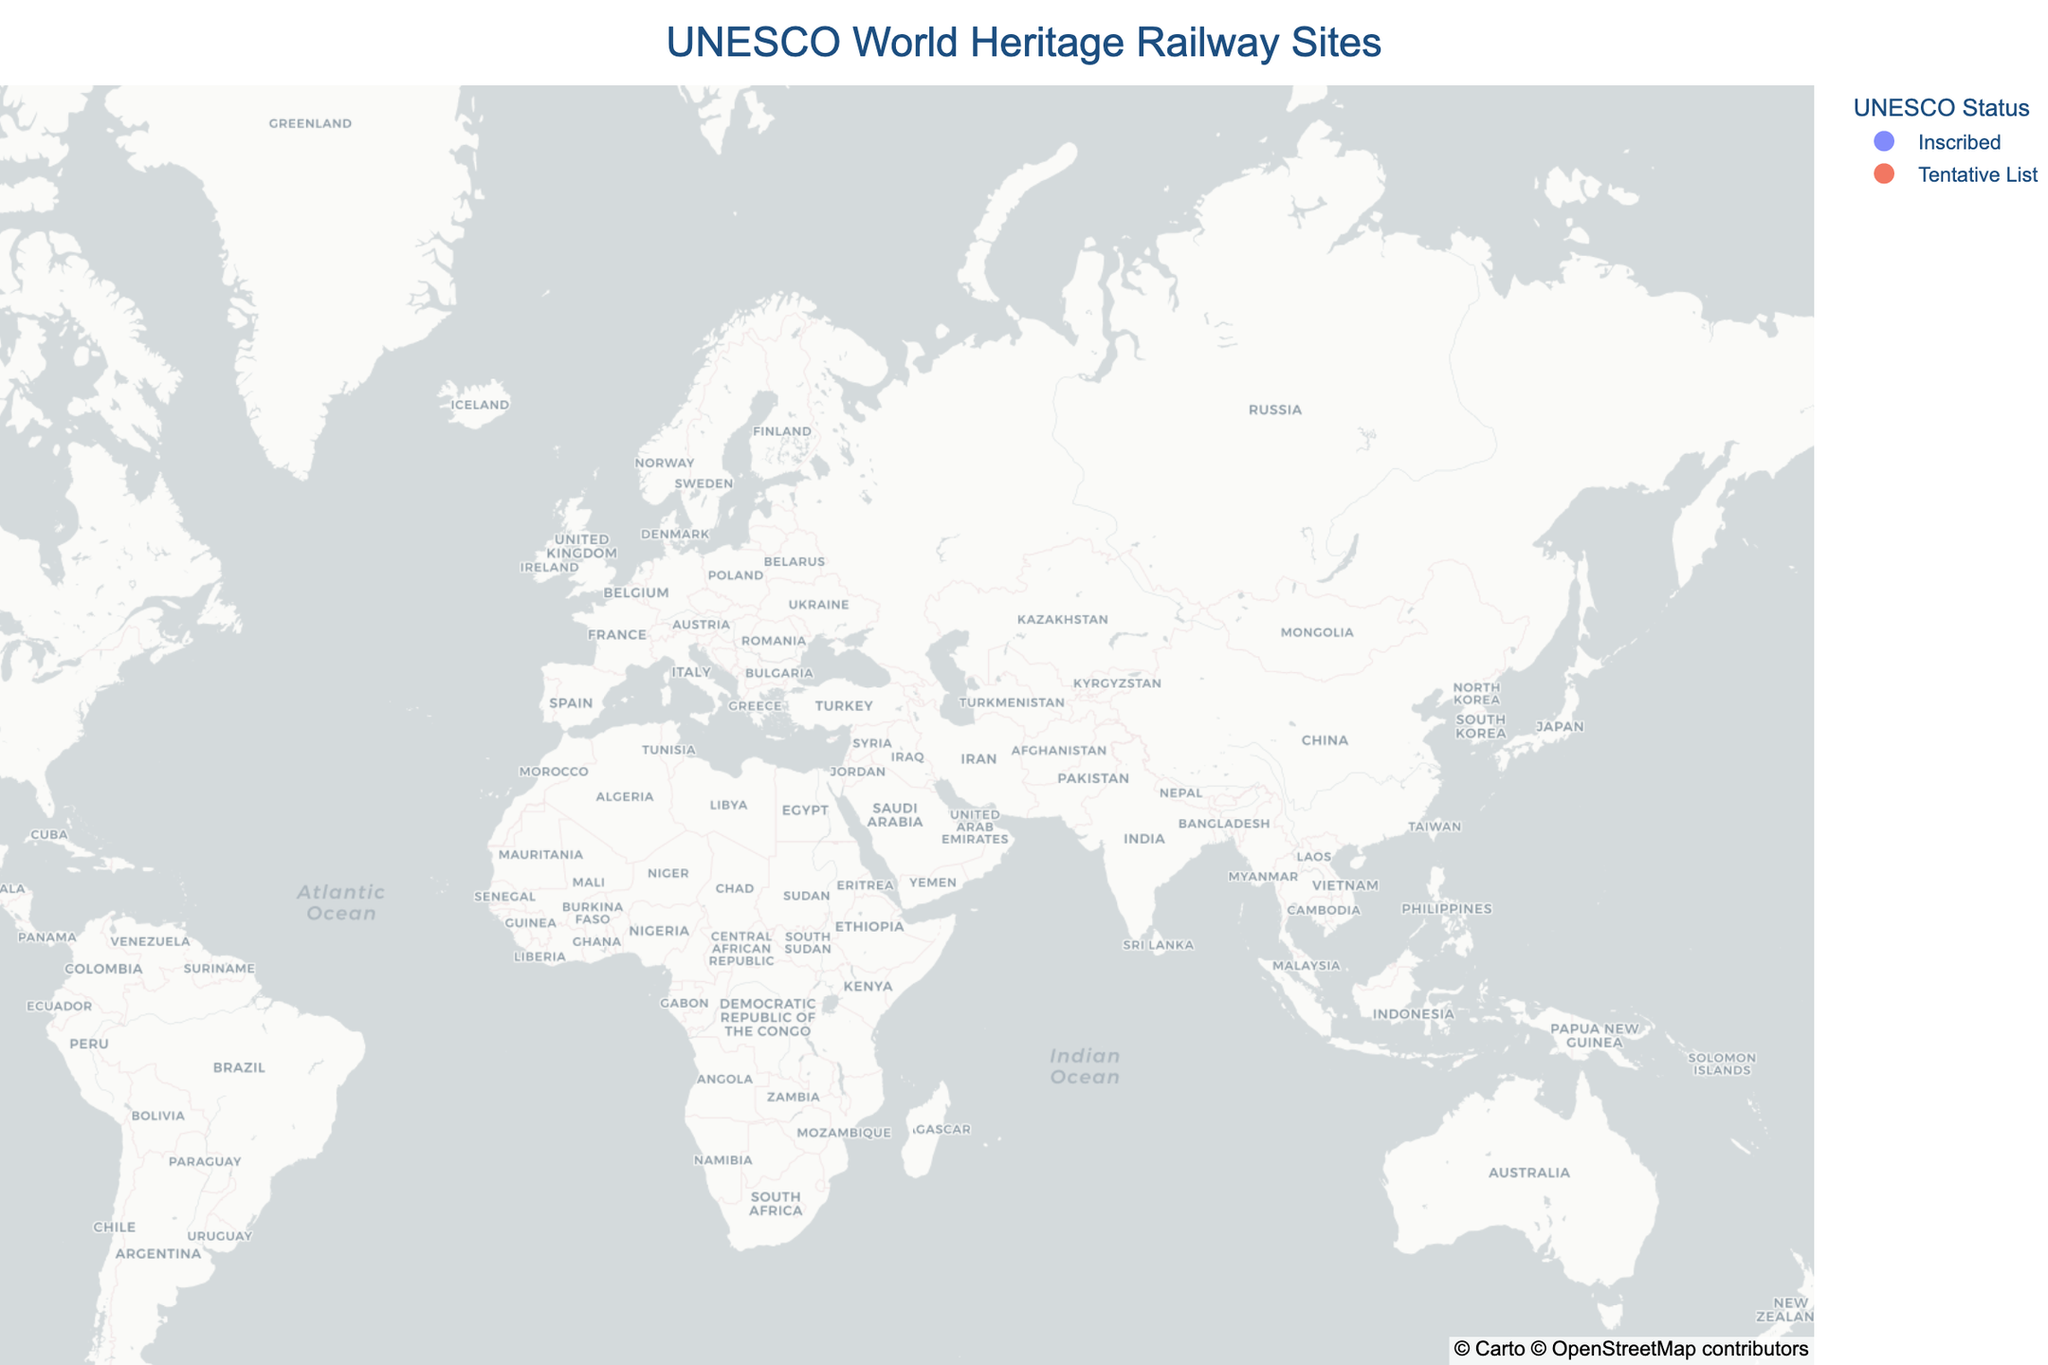What is the title of the map? The title can be found at the top center of the map. It reads "UNESCO World Heritage Railway Sites".
Answer: UNESCO World Heritage Railway Sites How many railway sites are listed as "Inscribed" by UNESCO? Look for the dots on the map that are color-coded for "Inscribed" status. Count these dots. There are 5: Semmering Railway, Darjeeling Himalayan Railway, Nilgiri Mountain Railway, Rhaetian Railway, and Mountain Railways of India.
Answer: 5 Which railway site on the map is associated with "Isambard Kingdom Brunel"? Hover over the dots and look at the cultural significance in the hover data. The dot that mentions "Isambard Kingdom Brunel" is the Great Western Railway.
Answer: Great Western Railway What's the earliest and latest year of inscription for the railway sites listed as "Inscribed"? Hover over the railway sites that are "Inscribed". Note the years listed under "Year Inscribed". The earliest year is 1998 and the latest is 2008.
Answer: 1998 and 2008 Which railway site on the map has the cultural significance of being the "First mountain railway in Europe"? Hover over the dots and check the cultural significance in the hover data for each site. The site with this significance is the Semmering Railway.
Answer: Semmering Railway Among the sites that are "Tentative List," which one is located in Russia? Hover over the dots classified as "Tentative List" and look for the location in the hover data. The dot located in Russia corresponds to the Trans-Siberian Railway.
Answer: Trans-Siberian Railway Which site has the most northern latitude, and what is its preservation status? Look at the latitudes of the various sites and identify the one with the highest latitude. The most northern site is the Trans-Siberian Railway, with a preservation status of "Continuously upgraded".
Answer: Trans-Siberian Railway, Continuously upgraded What is the preservation status of the Hejaz Railway, and what does it symbolize culturally? Hover over the Hejaz Railway dot and read the preservation status and cultural significance in the hover data. The preservation status is "Partially restored" and it symbolizes "Ottoman modernization".
Answer: Partially restored, Ottoman modernization Which railway site is an "Engineering marvel in steep terrain" and what year was it inscribed in? Hover over the dots on the map to find the one described as an "Engineering marvel in steep terrain". This is the Darjeeling Himalayan Railway, which was inscribed in 1999.
Answer: Darjeeling Himalayan Railway, 1999 